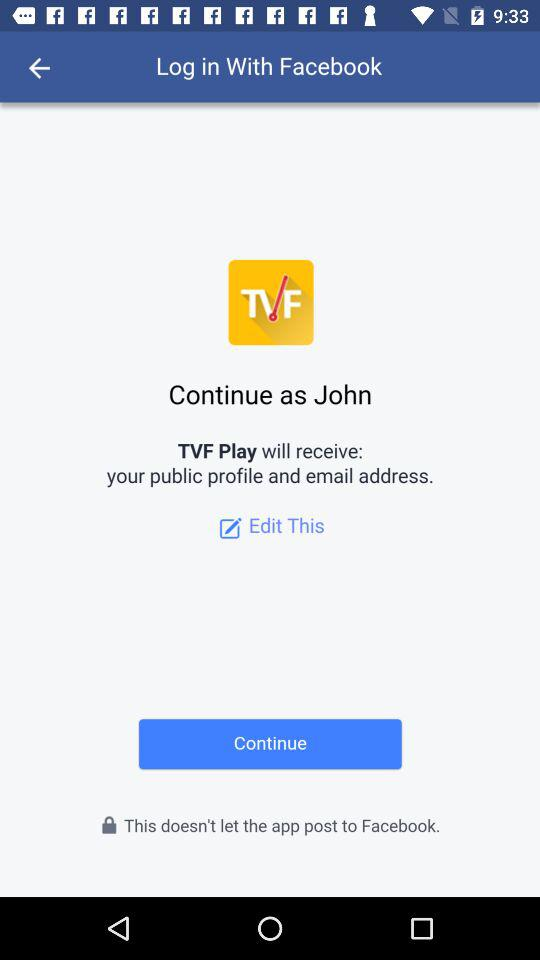What application is asking for permission? The application asking for permission is "TVF Play". 